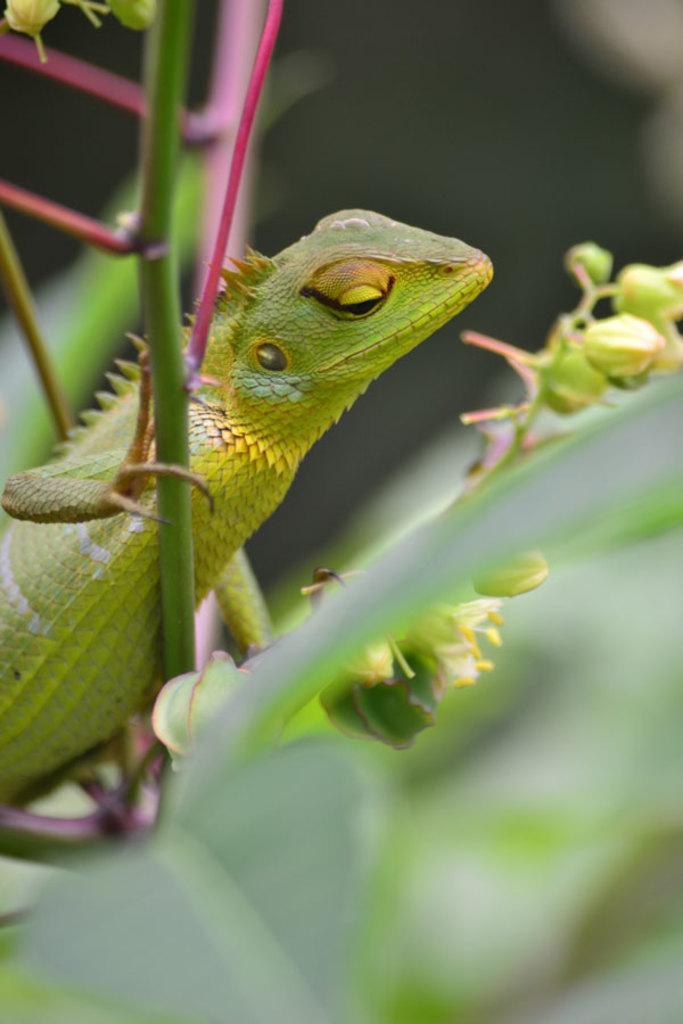Please provide a concise description of this image. In this image I can see a green anole on a plant. The background is blurred. 